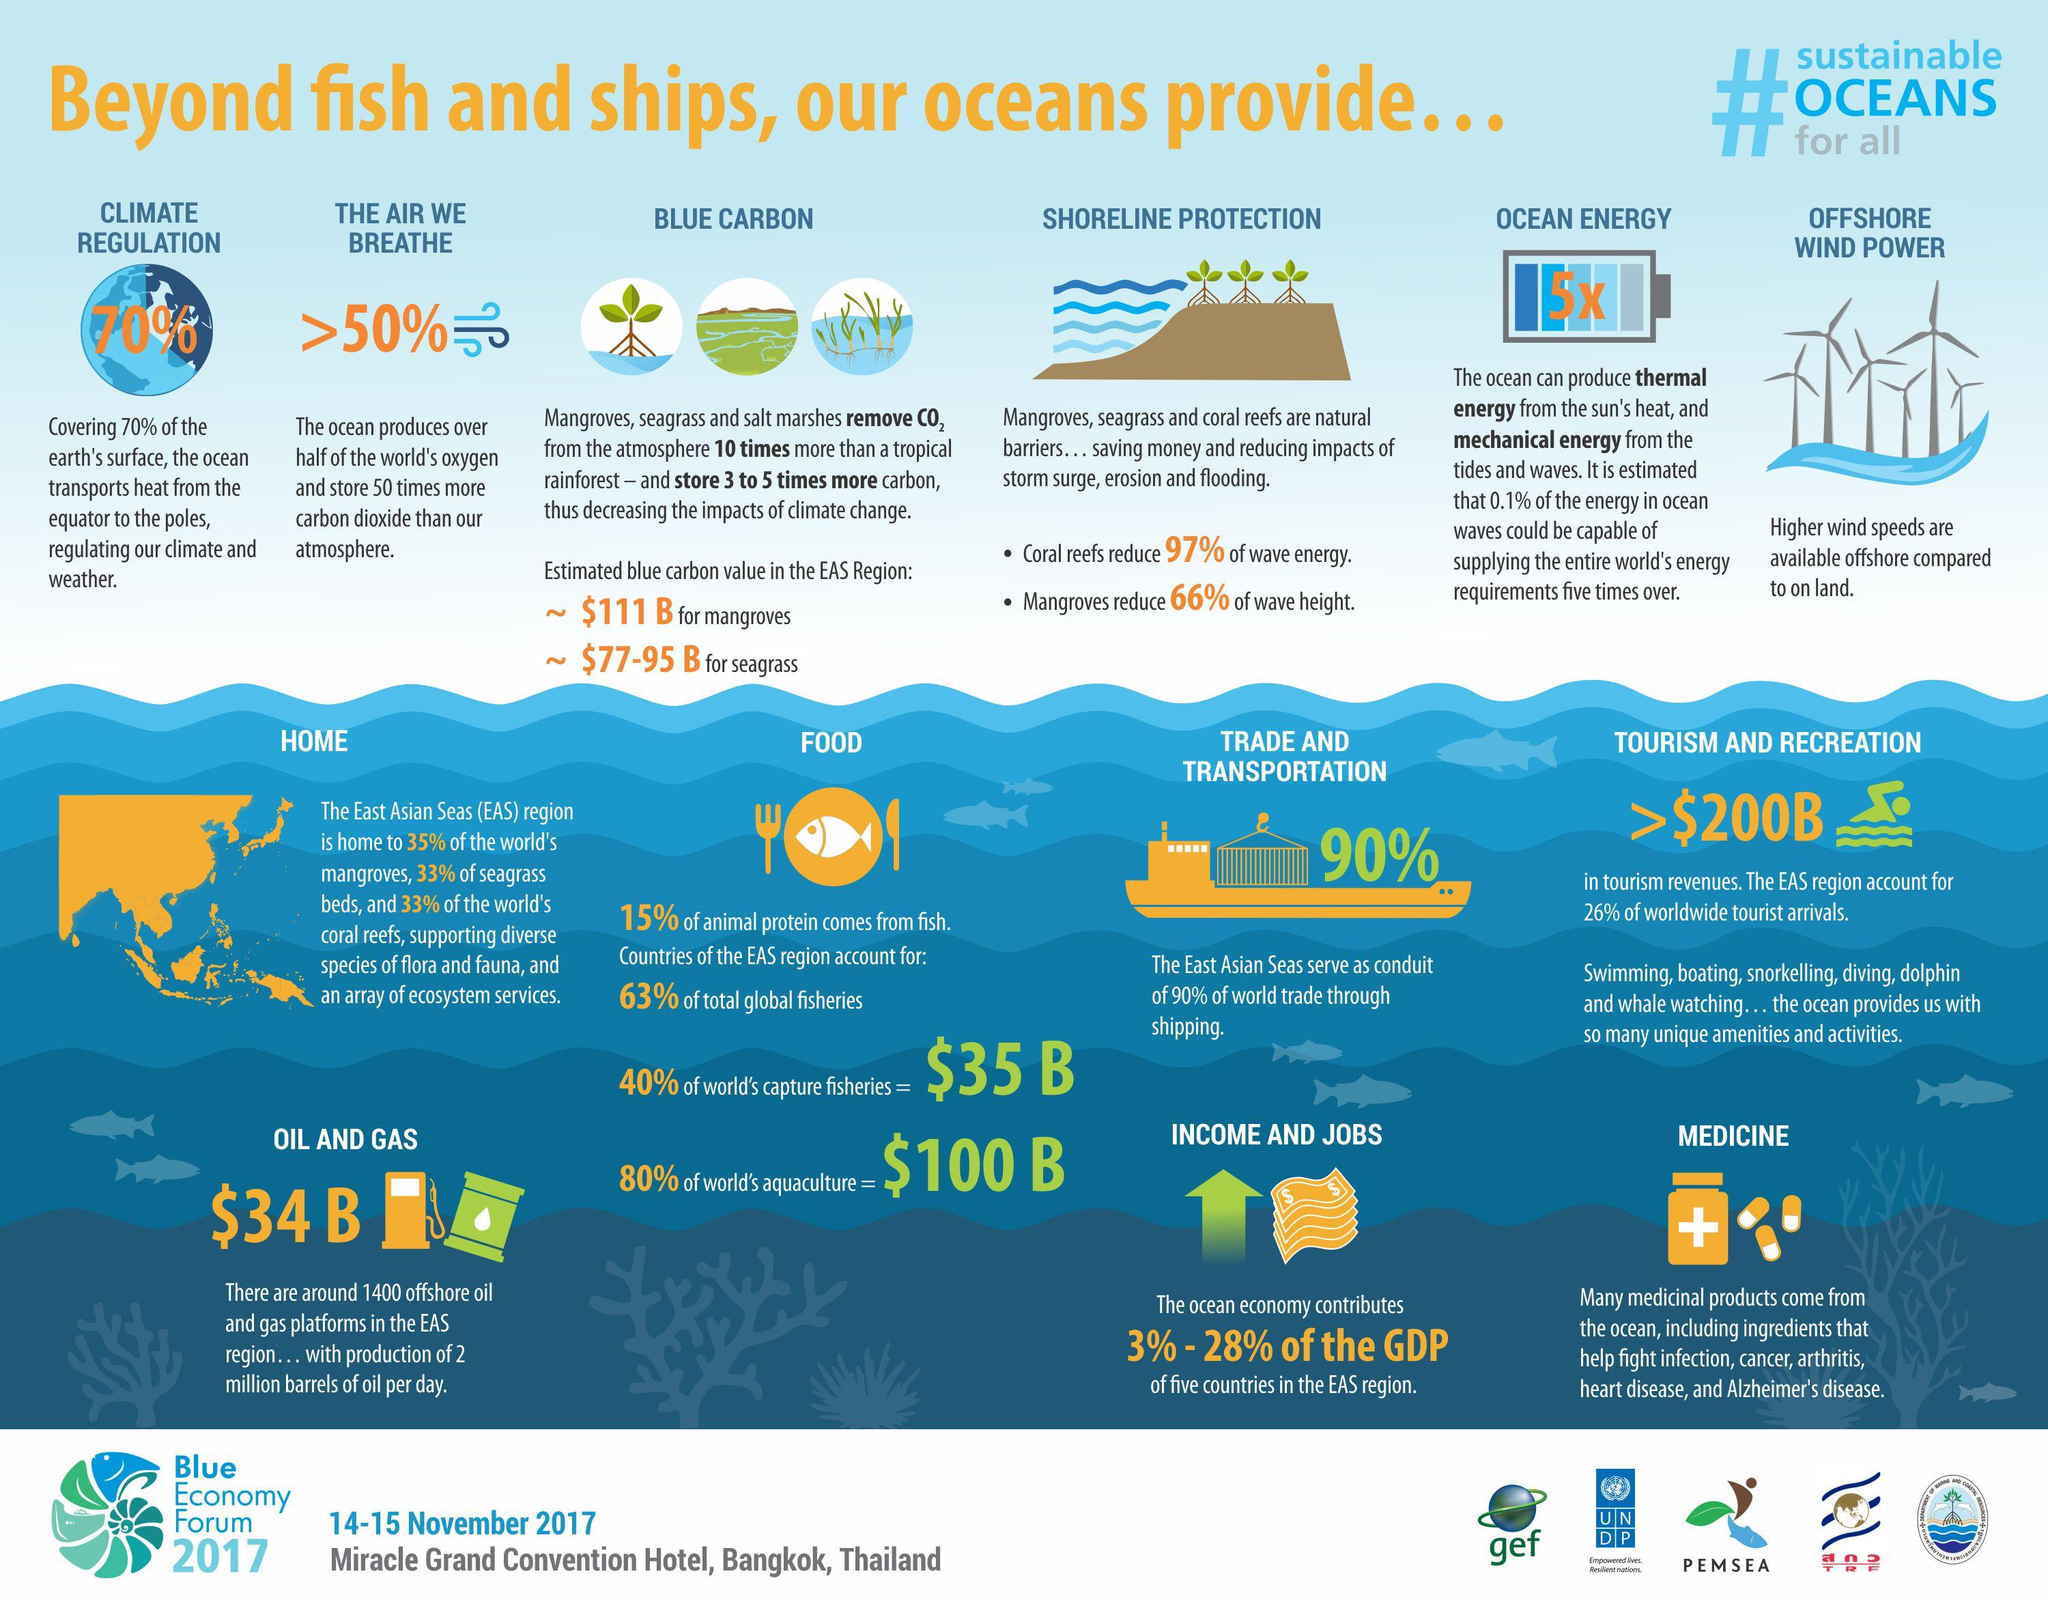Give some essential details in this illustration. In addition to providing fish and ships, oceans also offer a variety of other valuable resources, including water for drinking and irrigation, the regulation of climate, the generation of nutrients and oxygen, the transportation of sediments and nutrients, the support of biodiversity and the habitat of marine life, the carbon sequestration, the recreation and tourism, the mineral resources, the genetic resources, the energy and the food. The regulation of climate provided by oceans is 70%. Mangroves and seagrass are two essential ecosystems that help remove carbon dioxide from the atmosphere and provide coastal protection. By trapping sediment and nutrients, mangroves create rich, intertidal environments that support a diverse array of species. Meanwhile, seagrasses provide critical habitat for a multitude of marine animals, including fish, mollusks, and crustaceans. These underwater meadows also act as carbon sinks, sequestering carbon from the atmosphere and stabilizing the shoreline. Together, mangroves and seagrasses play a vital role in maintaining the delicate balance of our coastal ecosystems. 